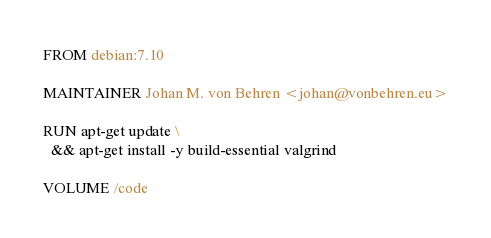Convert code to text. <code><loc_0><loc_0><loc_500><loc_500><_Dockerfile_>FROM debian:7.10

MAINTAINER Johan M. von Behren <johan@vonbehren.eu>

RUN apt-get update \
  && apt-get install -y build-essential valgrind

VOLUME /code
</code> 